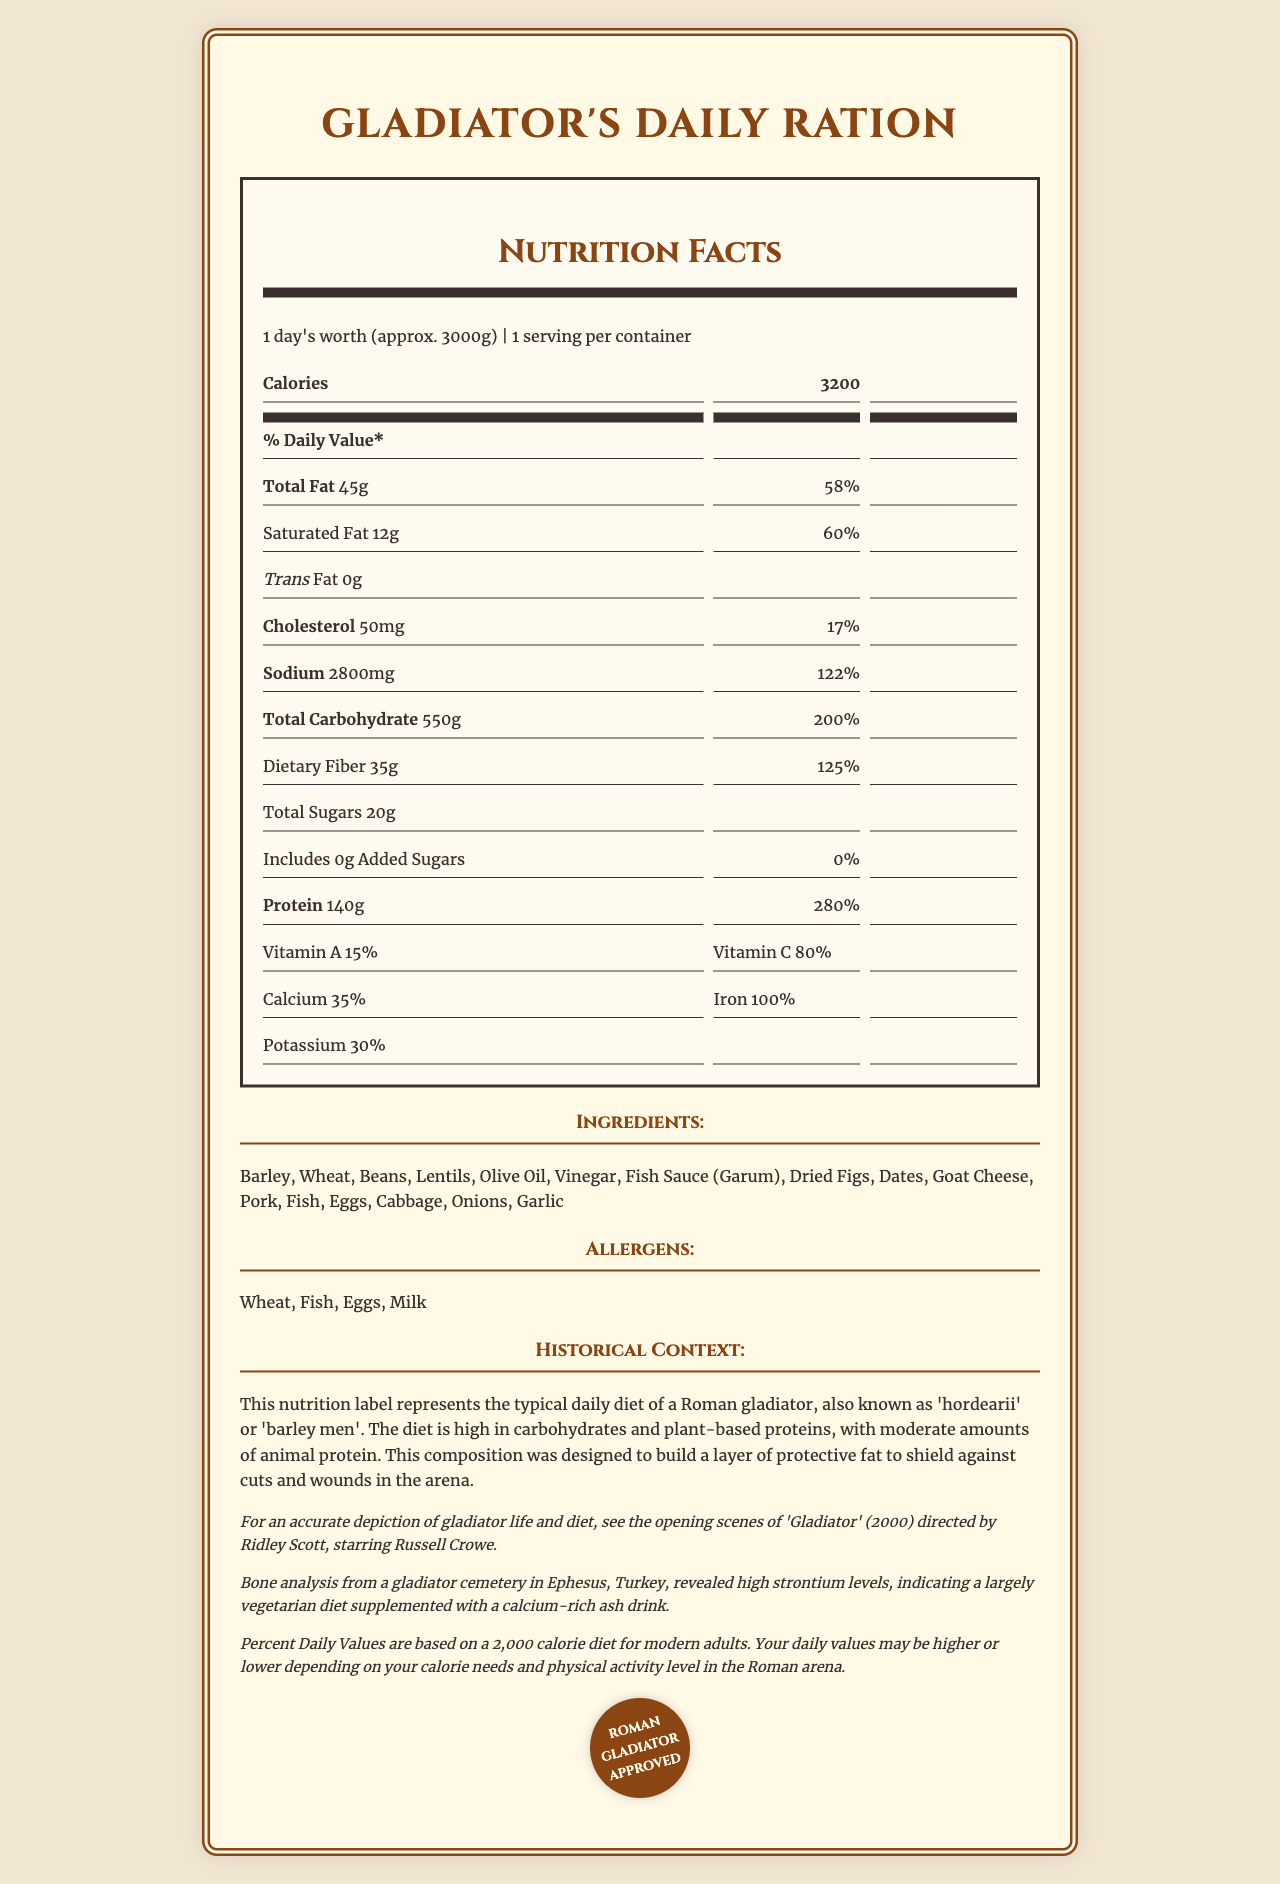what is the serving size of the Gladiator's Daily Ration? The serving size is stated as "1 day's worth (approx. 3000g)" in the document.
Answer: 1 day's worth (approx. 3000g) how much protein does one serving of Gladiator's Daily Ration provide? The document lists the protein content as "140g".
Answer: 140g describe the fat content in the Gladiator's Daily Ration. The document specifies the total fat content and breaks it down into saturated and trans fat.
Answer: The total fat is 45g, including 12g of saturated fat and 0g of trans fat. what kind of sugars are included in the Gladiator’s ration, and how much are they? The document specifies that there are 20g of total sugars and 0g of added sugars.
Answer: Total Sugars: 20g, Added Sugars: 0g what vitamins and minerals are highlighted in the Gladiator's Daily Ration? The document lists Vitamin A (15%), Vitamin C (80%), Calcium (35%), Iron (100%), and Potassium (30%).
Answer: Vitamin A, Vitamin C, Calcium, Iron, Potassium which ingredient does not belong to the list of ingredients in the Gladiator's Daily Ration? A. Barley B. Wheat C. Rice D. Lentils The list of ingredients includes Barley, Wheat, and Lentils, but not Rice.
Answer: C. Rice what is the total calorie count of the Gladiator's Daily Ration? A. 1500 B. 2000 C. 3200 D. 4000 The total calorie count provided in the document is 3200.
Answer: C. 3200 are there any allergens in the Gladiator's Daily Ration? The document lists allergens including Wheat, Fish, Eggs, and Milk.
Answer: Yes describe the historical context provided for the Gladiator's Daily Ration. The document provides detailed information about the purpose and design of the Roman gladiator diet.
Answer: This nutrition label represents the typical daily diet of a Roman gladiator, also known as 'hordearii' or 'barley men'. The diet is high in carbohydrates and plant-based proteins, with moderate amounts of animal protein. This composition was designed to build a layer of protective fat to shield against cuts and wounds in the arena. is there any information about the calcium content of the Gladiator's ration? The document states that the calcium content is 35% of the daily value.
Answer: Yes how does the Gladiator's ration from the document achieve its high plant-based protein content? The ingredients list contains these high-protein plant-based items, contributing significantly to the overall protein content.
Answer: By including ingredients such as barley, wheat, beans, and lentils. what kind of archaeological evidence supports the diet described in the document? The document provides this specific archaeological evidence backing the diet's accuracy.
Answer: Bone analysis from a gladiator cemetery in Ephesus, Turkey, revealed high strontium levels, indicating a largely vegetarian diet supplemented with a calcium-rich ash drink. which movie is recommended for an accurate depiction of gladiator life and diet? The document recommends this movie for an accurate depiction.
Answer: "Gladiator" (2000) directed by Ridley Scott, starring Russell Crowe what is the purpose of the diet's high carbohydrate and plant-based protein content as per the document? The document explains that the diet was designed to protect gladiators during combat.
Answer: To build a layer of protective fat to shield against cuts and wounds in the arena. how many servings per container does the Gladiator's Daily Ration have? A. 1 B. 2 C. 3 D. 4 The document states that there is 1 serving per container.
Answer: A. 1 what is the name given to Roman gladiators related to their diet? The document refers to Roman gladiators with these terms as related to their diet.
Answer: 'Hordearii' or 'barley men' does the document provide any information about the exact modern daily values? The document includes a disclaimer mentioning the basis for daily values but does not provide precise modern daily values.
Answer: No, it states that the daily values are based on a 2,000 calorie diet for modern adults, but specific values are not provided. summarize the main idea of the document. The summary explains that the document offers comprehensive insight into the diet of a Roman gladiator, supported by various forms of historical and cultural information.
Answer: The document provides a detailed nutrition label for the typical daily diet of a Roman gladiator, including ingredient and nutrient information, historical context, archaeological evidence supporting the diet, and a movie reference for a historically accurate depiction of gladiator life. 